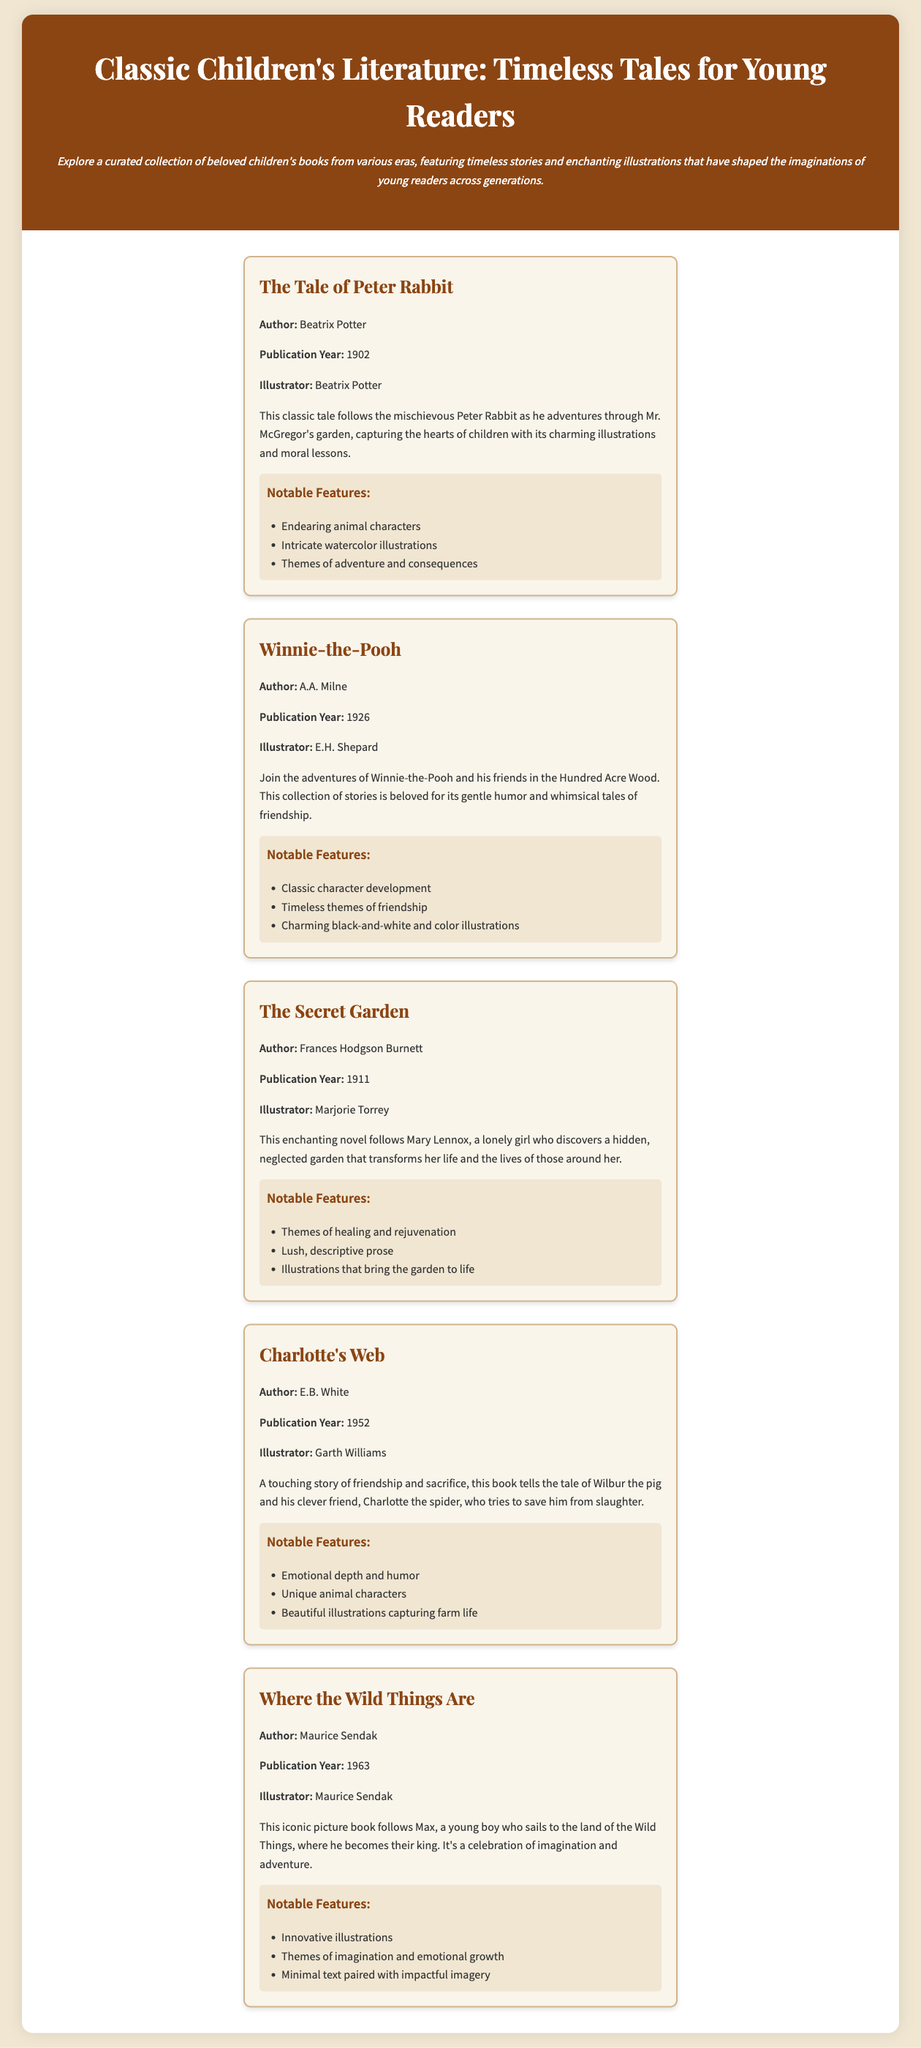What is the title of the first book listed? The first book listed in the document is "The Tale of Peter Rabbit."
Answer: The Tale of Peter Rabbit Who is the author of "Charlotte's Web"? The author of "Charlotte's Web" is E.B. White.
Answer: E.B. White In what year was "Winnie-the-Pooh" published? "Winnie-the-Pooh" was published in 1926.
Answer: 1926 Which book features a character named Max? The book featuring a character named Max is "Where the Wild Things Are."
Answer: Where the Wild Things Are What is a notable theme in "The Secret Garden"? A notable theme in "The Secret Garden" is healing and rejuvenation.
Answer: Healing and rejuvenation Who illustrated "The Tale of Peter Rabbit"? The illustrator of "The Tale of Peter Rabbit" is Beatrix Potter.
Answer: Beatrix Potter Which book was published most recently? The most recently published book in the document is "Where the Wild Things Are" from 1963.
Answer: Where the Wild Things Are What type of illustrations can be found in "Winnie-the-Pooh"? The book "Winnie-the-Pooh" features charming black-and-white and color illustrations.
Answer: Charming black-and-white and color illustrations What is the primary focus of the document? The primary focus of the document is a curated collection of beloved children's books.
Answer: A curated collection of beloved children's books 